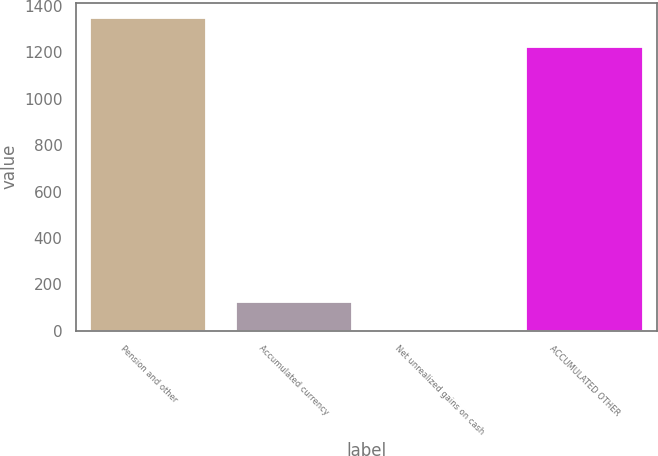Convert chart. <chart><loc_0><loc_0><loc_500><loc_500><bar_chart><fcel>Pension and other<fcel>Accumulated currency<fcel>Net unrealized gains on cash<fcel>ACCUMULATED OTHER<nl><fcel>1347.88<fcel>122.78<fcel>0.2<fcel>1225.3<nl></chart> 